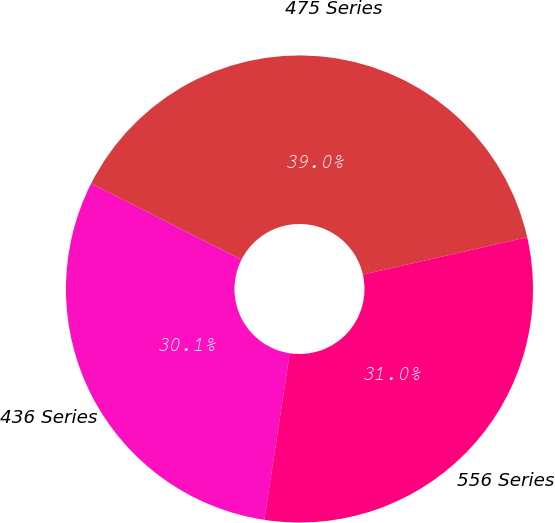<chart> <loc_0><loc_0><loc_500><loc_500><pie_chart><fcel>436 Series<fcel>475 Series<fcel>556 Series<nl><fcel>30.06%<fcel>38.98%<fcel>30.96%<nl></chart> 